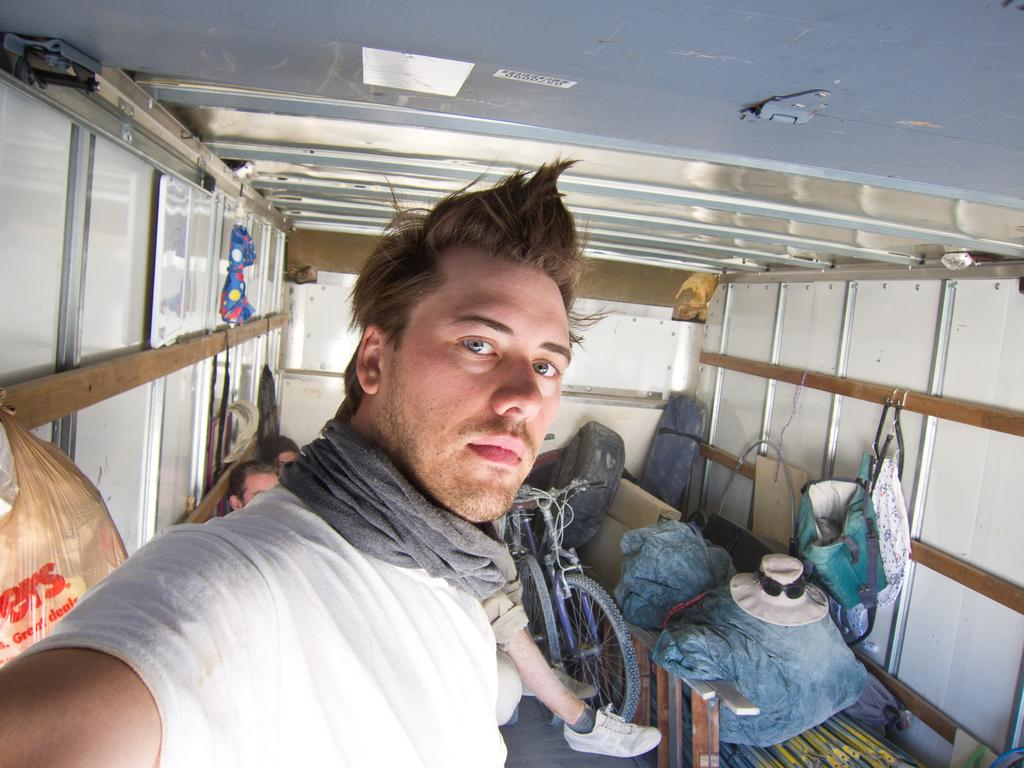What is the person in the image doing? The person in the image is taking a picture. What are the other people in the image doing? The other people in the image are sitting. What objects can be seen in the image besides the people? There are bags visible in the image. What type of zinc is being used to create a riddle in the image? There is no zinc or riddle present in the image. How many cattle can be seen grazing in the image? There are no cattle present in the image. 